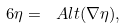<formula> <loc_0><loc_0><loc_500><loc_500>\ 6 \eta = \ A l t ( \nabla \eta ) ,</formula> 